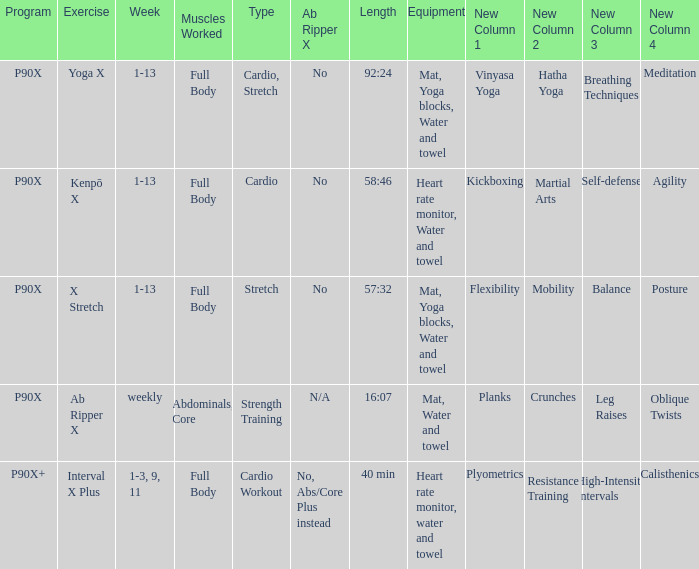What are the total cardio categories? 1.0. 